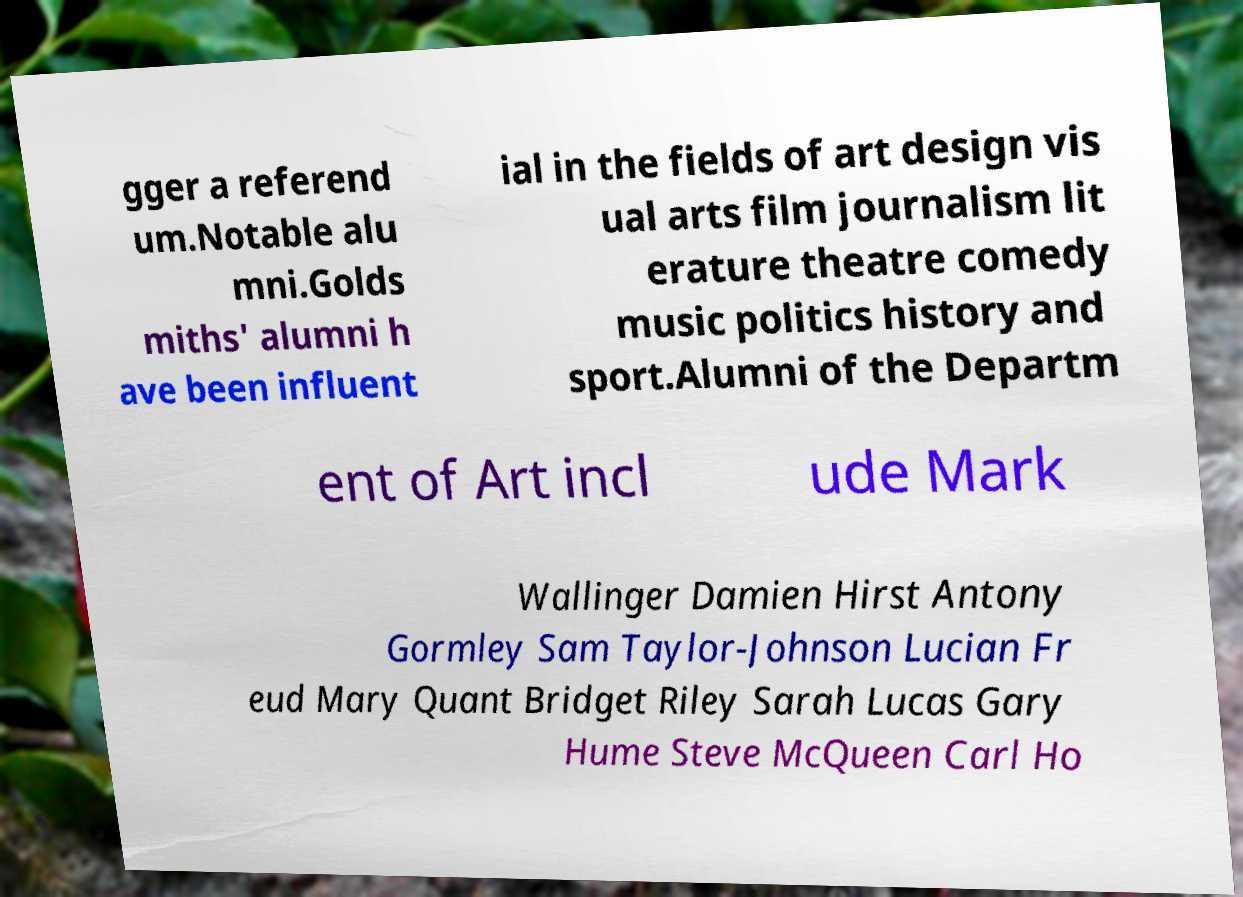There's text embedded in this image that I need extracted. Can you transcribe it verbatim? gger a referend um.Notable alu mni.Golds miths' alumni h ave been influent ial in the fields of art design vis ual arts film journalism lit erature theatre comedy music politics history and sport.Alumni of the Departm ent of Art incl ude Mark Wallinger Damien Hirst Antony Gormley Sam Taylor-Johnson Lucian Fr eud Mary Quant Bridget Riley Sarah Lucas Gary Hume Steve McQueen Carl Ho 